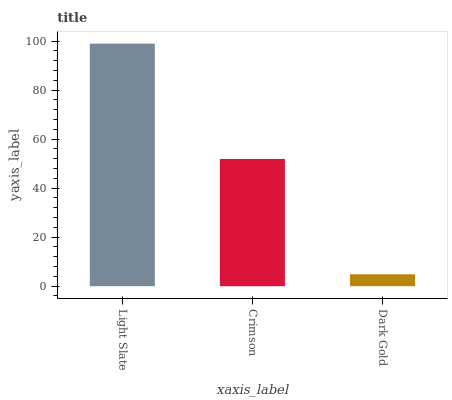Is Dark Gold the minimum?
Answer yes or no. Yes. Is Light Slate the maximum?
Answer yes or no. Yes. Is Crimson the minimum?
Answer yes or no. No. Is Crimson the maximum?
Answer yes or no. No. Is Light Slate greater than Crimson?
Answer yes or no. Yes. Is Crimson less than Light Slate?
Answer yes or no. Yes. Is Crimson greater than Light Slate?
Answer yes or no. No. Is Light Slate less than Crimson?
Answer yes or no. No. Is Crimson the high median?
Answer yes or no. Yes. Is Crimson the low median?
Answer yes or no. Yes. Is Dark Gold the high median?
Answer yes or no. No. Is Dark Gold the low median?
Answer yes or no. No. 